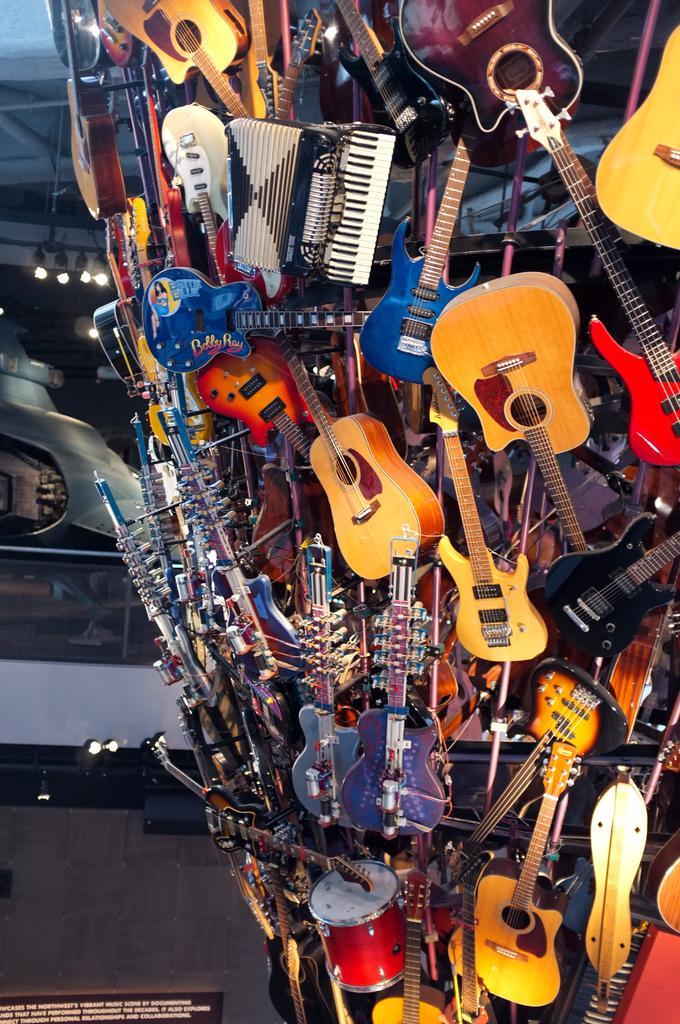Could you give a brief overview of what you see in this image? There are many musical instruments attached to an object. 